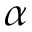<formula> <loc_0><loc_0><loc_500><loc_500>\alpha</formula> 